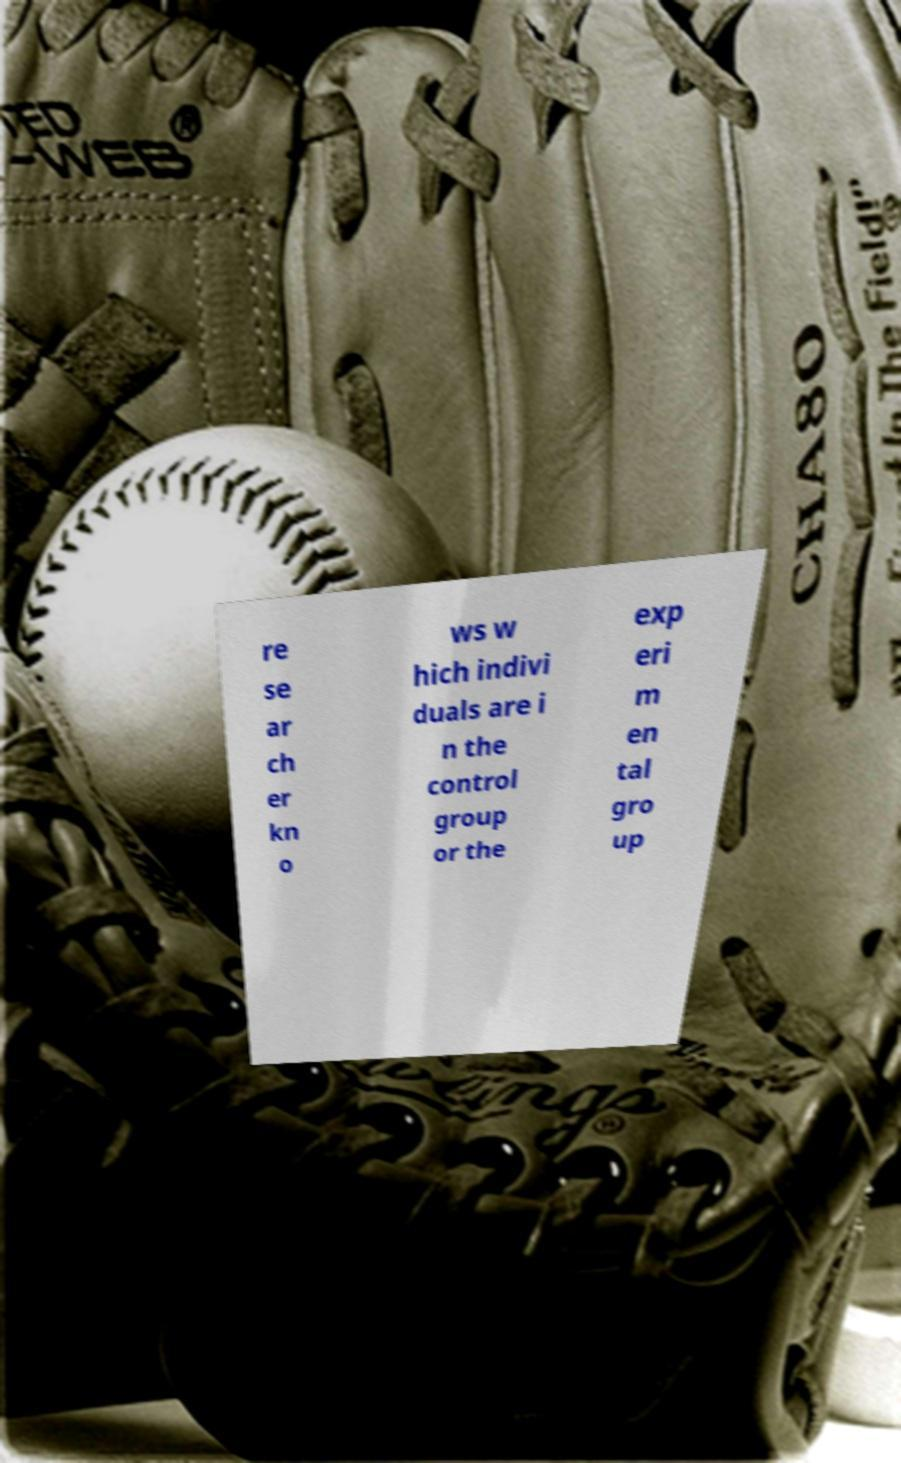For documentation purposes, I need the text within this image transcribed. Could you provide that? re se ar ch er kn o ws w hich indivi duals are i n the control group or the exp eri m en tal gro up 